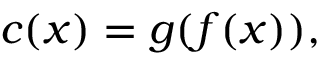<formula> <loc_0><loc_0><loc_500><loc_500>c ( x ) = g ( f ( x ) ) ,</formula> 